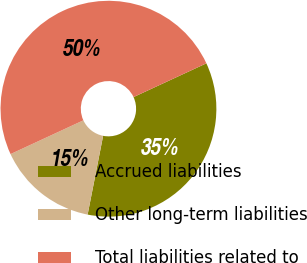<chart> <loc_0><loc_0><loc_500><loc_500><pie_chart><fcel>Accrued liabilities<fcel>Other long-term liabilities<fcel>Total liabilities related to<nl><fcel>35.0%<fcel>15.0%<fcel>50.0%<nl></chart> 